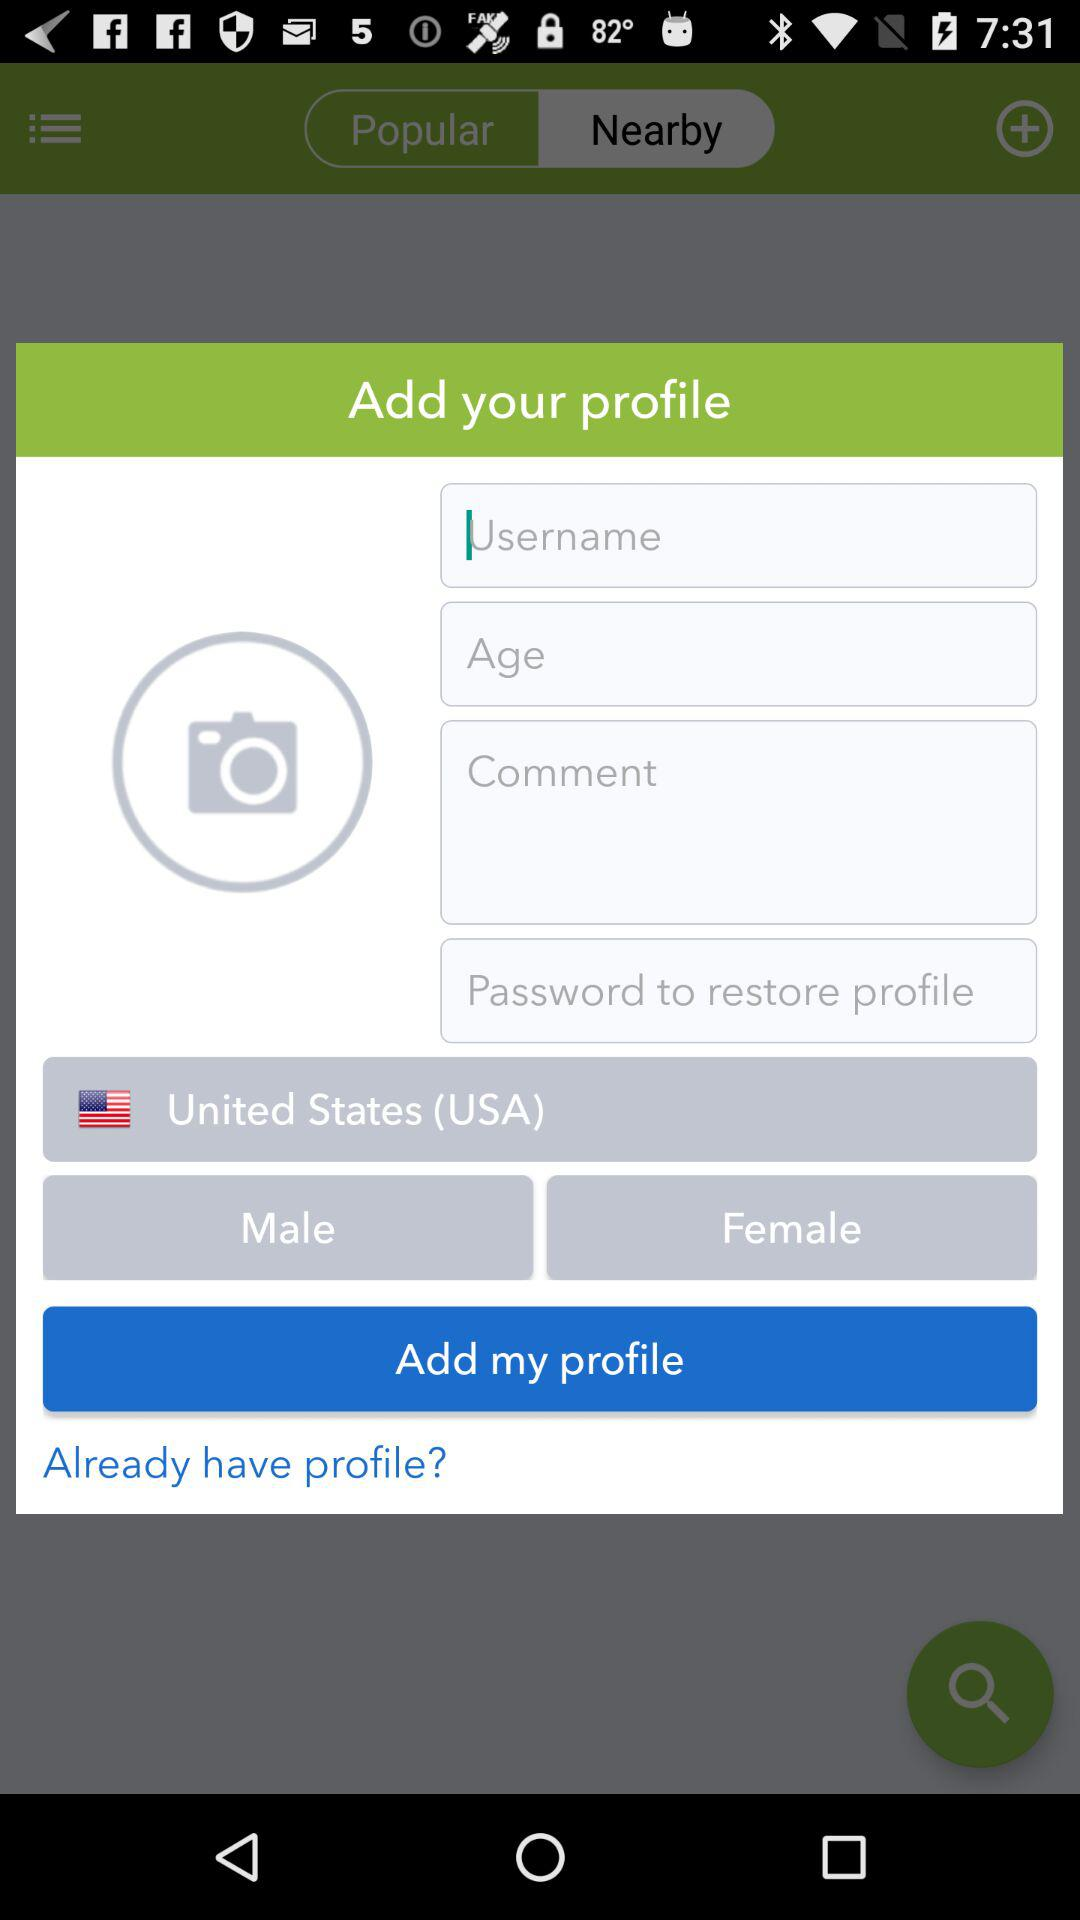How old is the user?
When the provided information is insufficient, respond with <no answer>. <no answer> 